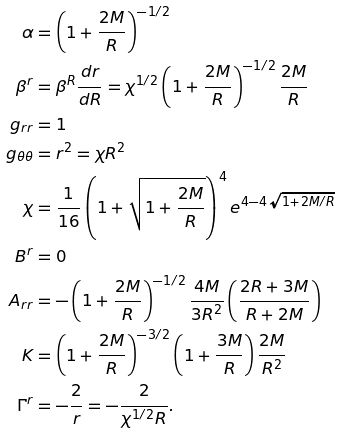<formula> <loc_0><loc_0><loc_500><loc_500>\alpha & = \left ( 1 + \frac { 2 M } { R } \right ) ^ { - 1 / 2 } \\ \beta ^ { r } & = \beta ^ { R } \frac { d r } { d R } = \chi ^ { 1 / 2 } \left ( 1 + \frac { 2 M } { R } \right ) ^ { - 1 / 2 } \frac { 2 M } { R } \\ g _ { r r } & = 1 \\ g _ { \theta \theta } & = r ^ { 2 } = \chi R ^ { 2 } \\ \chi & = \frac { 1 } { 1 6 } \left ( 1 + \sqrt { 1 + \frac { 2 M } { R } } \right ) ^ { 4 } e ^ { 4 - 4 \sqrt { 1 + 2 M / R } } \\ B ^ { r } & = 0 \\ A _ { r r } & = - \left ( 1 + \frac { 2 M } { R } \right ) ^ { - 1 / 2 } \frac { 4 M } { 3 R ^ { 2 } } \left ( \frac { 2 R + 3 M } { R + 2 M } \right ) \\ K & = \left ( 1 + \frac { 2 M } { R } \right ) ^ { - 3 / 2 } \left ( 1 + \frac { 3 M } { R } \right ) \frac { 2 M } { R ^ { 2 } } \\ \Gamma ^ { r } & = - \frac { 2 } { r } = - \frac { 2 } { \chi ^ { 1 / 2 } R } .</formula> 